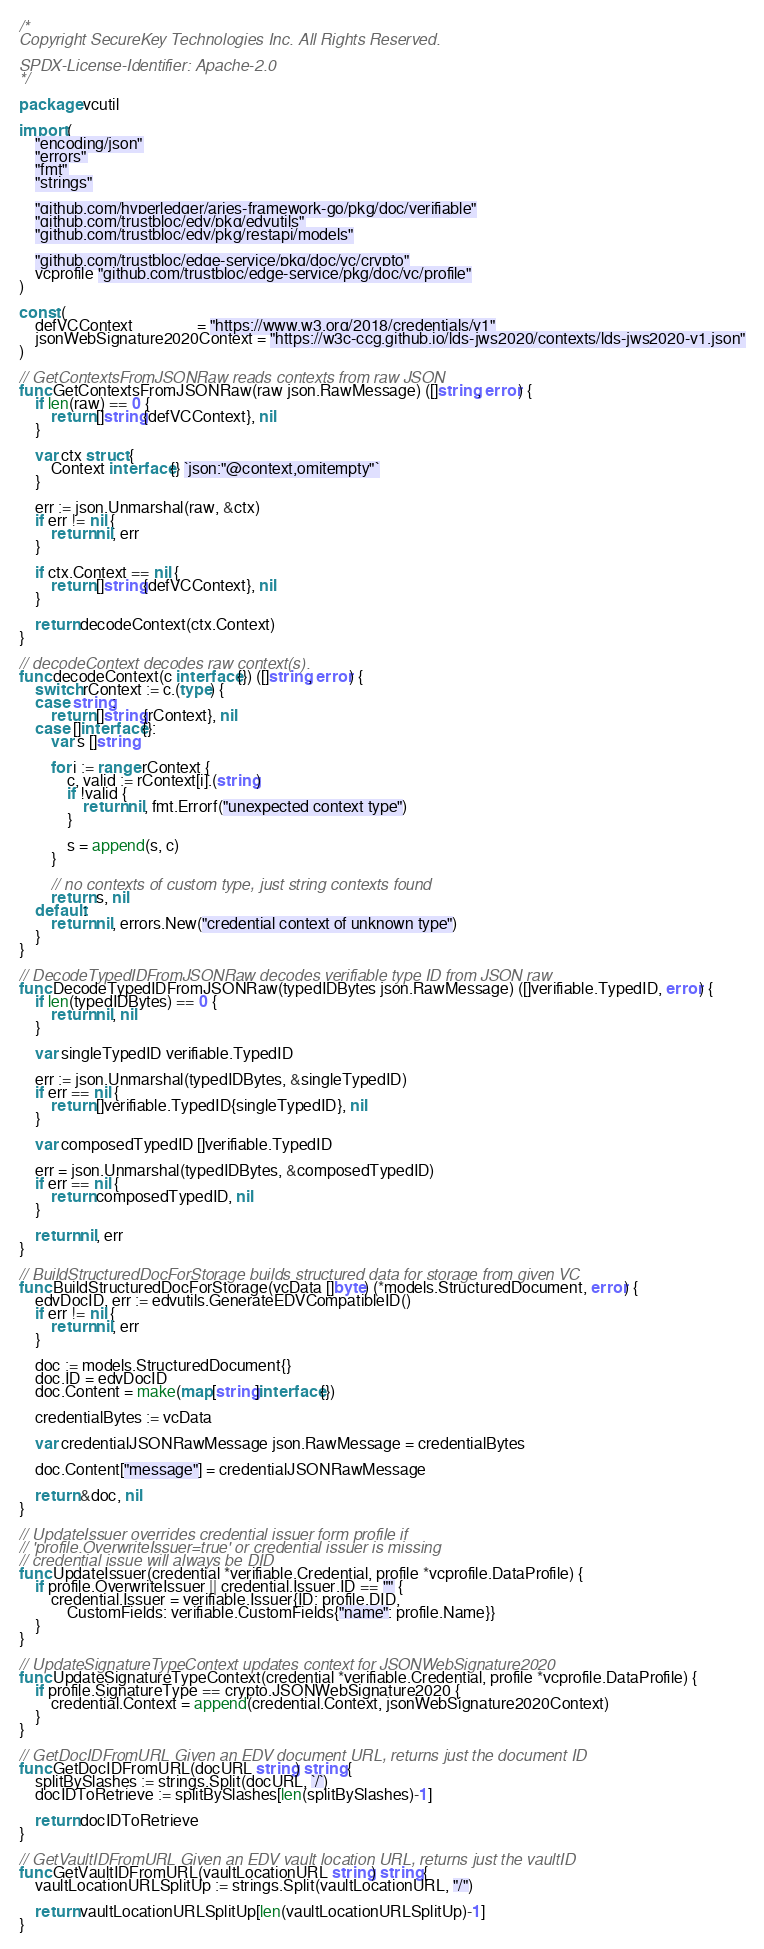<code> <loc_0><loc_0><loc_500><loc_500><_Go_>/*
Copyright SecureKey Technologies Inc. All Rights Reserved.

SPDX-License-Identifier: Apache-2.0
*/

package vcutil

import (
	"encoding/json"
	"errors"
	"fmt"
	"strings"

	"github.com/hyperledger/aries-framework-go/pkg/doc/verifiable"
	"github.com/trustbloc/edv/pkg/edvutils"
	"github.com/trustbloc/edv/pkg/restapi/models"

	"github.com/trustbloc/edge-service/pkg/doc/vc/crypto"
	vcprofile "github.com/trustbloc/edge-service/pkg/doc/vc/profile"
)

const (
	defVCContext                = "https://www.w3.org/2018/credentials/v1"
	jsonWebSignature2020Context = "https://w3c-ccg.github.io/lds-jws2020/contexts/lds-jws2020-v1.json"
)

// GetContextsFromJSONRaw reads contexts from raw JSON
func GetContextsFromJSONRaw(raw json.RawMessage) ([]string, error) {
	if len(raw) == 0 {
		return []string{defVCContext}, nil
	}

	var ctx struct {
		Context interface{} `json:"@context,omitempty"`
	}

	err := json.Unmarshal(raw, &ctx)
	if err != nil {
		return nil, err
	}

	if ctx.Context == nil {
		return []string{defVCContext}, nil
	}

	return decodeContext(ctx.Context)
}

// decodeContext decodes raw context(s).
func decodeContext(c interface{}) ([]string, error) {
	switch rContext := c.(type) {
	case string:
		return []string{rContext}, nil
	case []interface{}:
		var s []string

		for i := range rContext {
			c, valid := rContext[i].(string)
			if !valid {
				return nil, fmt.Errorf("unexpected context type")
			}

			s = append(s, c)
		}

		// no contexts of custom type, just string contexts found
		return s, nil
	default:
		return nil, errors.New("credential context of unknown type")
	}
}

// DecodeTypedIDFromJSONRaw decodes verifiable type ID from JSON raw
func DecodeTypedIDFromJSONRaw(typedIDBytes json.RawMessage) ([]verifiable.TypedID, error) {
	if len(typedIDBytes) == 0 {
		return nil, nil
	}

	var singleTypedID verifiable.TypedID

	err := json.Unmarshal(typedIDBytes, &singleTypedID)
	if err == nil {
		return []verifiable.TypedID{singleTypedID}, nil
	}

	var composedTypedID []verifiable.TypedID

	err = json.Unmarshal(typedIDBytes, &composedTypedID)
	if err == nil {
		return composedTypedID, nil
	}

	return nil, err
}

// BuildStructuredDocForStorage builds structured data for storage from given VC
func BuildStructuredDocForStorage(vcData []byte) (*models.StructuredDocument, error) {
	edvDocID, err := edvutils.GenerateEDVCompatibleID()
	if err != nil {
		return nil, err
	}

	doc := models.StructuredDocument{}
	doc.ID = edvDocID
	doc.Content = make(map[string]interface{})

	credentialBytes := vcData

	var credentialJSONRawMessage json.RawMessage = credentialBytes

	doc.Content["message"] = credentialJSONRawMessage

	return &doc, nil
}

// UpdateIssuer overrides credential issuer form profile if
// 'profile.OverwriteIssuer=true' or credential issuer is missing
// credential issue will always be DID
func UpdateIssuer(credential *verifiable.Credential, profile *vcprofile.DataProfile) {
	if profile.OverwriteIssuer || credential.Issuer.ID == "" {
		credential.Issuer = verifiable.Issuer{ID: profile.DID,
			CustomFields: verifiable.CustomFields{"name": profile.Name}}
	}
}

// UpdateSignatureTypeContext updates context for JSONWebSignature2020
func UpdateSignatureTypeContext(credential *verifiable.Credential, profile *vcprofile.DataProfile) {
	if profile.SignatureType == crypto.JSONWebSignature2020 {
		credential.Context = append(credential.Context, jsonWebSignature2020Context)
	}
}

// GetDocIDFromURL Given an EDV document URL, returns just the document ID
func GetDocIDFromURL(docURL string) string {
	splitBySlashes := strings.Split(docURL, `/`)
	docIDToRetrieve := splitBySlashes[len(splitBySlashes)-1]

	return docIDToRetrieve
}

// GetVaultIDFromURL Given an EDV vault location URL, returns just the vaultID
func GetVaultIDFromURL(vaultLocationURL string) string {
	vaultLocationURLSplitUp := strings.Split(vaultLocationURL, "/")

	return vaultLocationURLSplitUp[len(vaultLocationURLSplitUp)-1]
}
</code> 